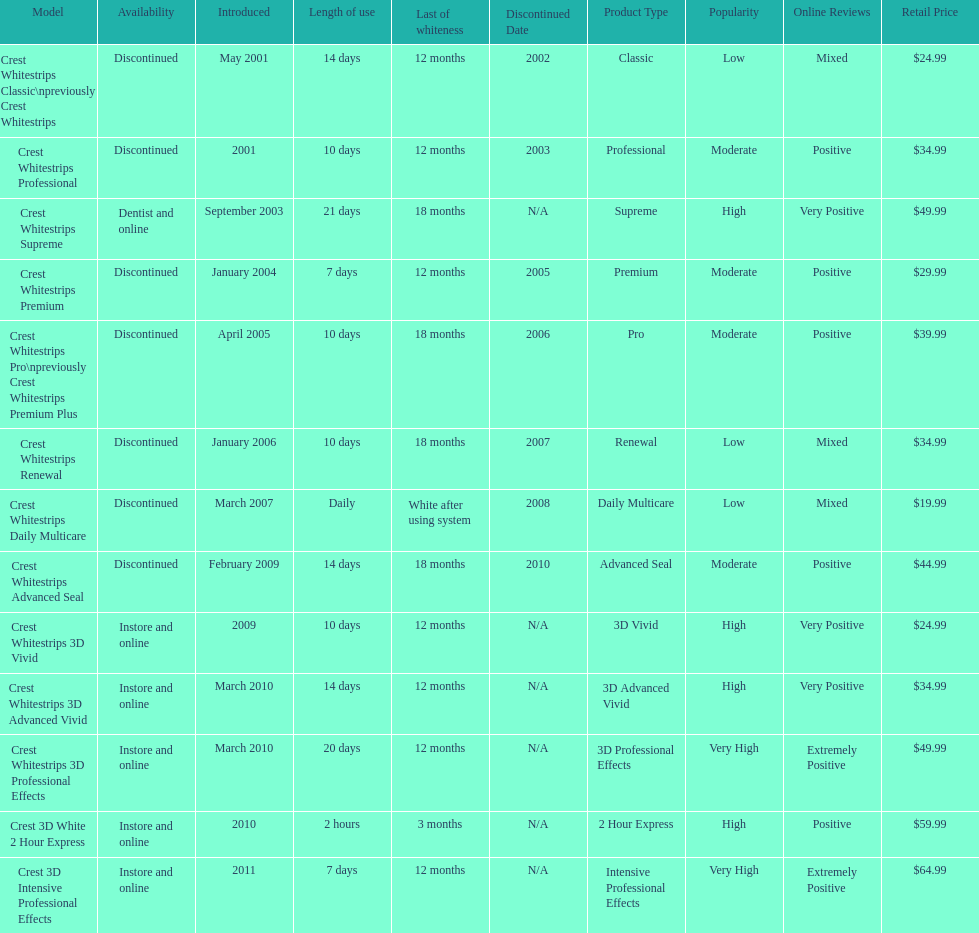Which discontinued product was introduced the same year as crest whitestrips 3d vivid? Crest Whitestrips Advanced Seal. 